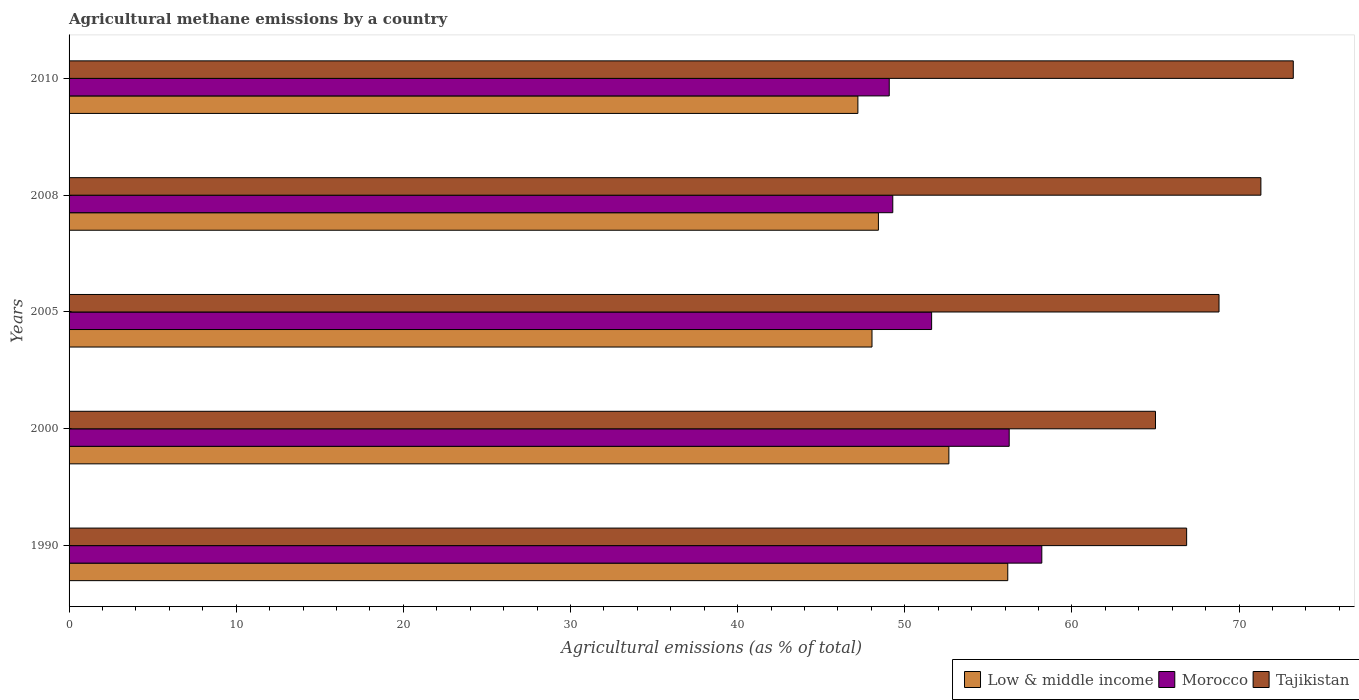Are the number of bars on each tick of the Y-axis equal?
Your answer should be compact. Yes. How many bars are there on the 3rd tick from the bottom?
Ensure brevity in your answer.  3. What is the label of the 3rd group of bars from the top?
Give a very brief answer. 2005. In how many cases, is the number of bars for a given year not equal to the number of legend labels?
Give a very brief answer. 0. What is the amount of agricultural methane emitted in Morocco in 2010?
Provide a succinct answer. 49.07. Across all years, what is the maximum amount of agricultural methane emitted in Morocco?
Give a very brief answer. 58.2. Across all years, what is the minimum amount of agricultural methane emitted in Low & middle income?
Give a very brief answer. 47.19. In which year was the amount of agricultural methane emitted in Low & middle income minimum?
Keep it short and to the point. 2010. What is the total amount of agricultural methane emitted in Low & middle income in the graph?
Provide a succinct answer. 252.44. What is the difference between the amount of agricultural methane emitted in Tajikistan in 2005 and that in 2010?
Keep it short and to the point. -4.44. What is the difference between the amount of agricultural methane emitted in Low & middle income in 1990 and the amount of agricultural methane emitted in Tajikistan in 2010?
Keep it short and to the point. -17.08. What is the average amount of agricultural methane emitted in Low & middle income per year?
Offer a terse response. 50.49. In the year 2008, what is the difference between the amount of agricultural methane emitted in Tajikistan and amount of agricultural methane emitted in Low & middle income?
Offer a very short reply. 22.88. What is the ratio of the amount of agricultural methane emitted in Low & middle income in 2000 to that in 2008?
Keep it short and to the point. 1.09. Is the difference between the amount of agricultural methane emitted in Tajikistan in 1990 and 2000 greater than the difference between the amount of agricultural methane emitted in Low & middle income in 1990 and 2000?
Your answer should be compact. No. What is the difference between the highest and the second highest amount of agricultural methane emitted in Morocco?
Provide a short and direct response. 1.95. What is the difference between the highest and the lowest amount of agricultural methane emitted in Morocco?
Make the answer very short. 9.13. What does the 1st bar from the top in 2008 represents?
Make the answer very short. Tajikistan. What does the 1st bar from the bottom in 2000 represents?
Keep it short and to the point. Low & middle income. Is it the case that in every year, the sum of the amount of agricultural methane emitted in Tajikistan and amount of agricultural methane emitted in Morocco is greater than the amount of agricultural methane emitted in Low & middle income?
Your response must be concise. Yes. Are all the bars in the graph horizontal?
Ensure brevity in your answer.  Yes. What is the difference between two consecutive major ticks on the X-axis?
Your answer should be very brief. 10. Are the values on the major ticks of X-axis written in scientific E-notation?
Give a very brief answer. No. Does the graph contain any zero values?
Provide a succinct answer. No. Where does the legend appear in the graph?
Your answer should be compact. Bottom right. How are the legend labels stacked?
Keep it short and to the point. Horizontal. What is the title of the graph?
Keep it short and to the point. Agricultural methane emissions by a country. Does "Micronesia" appear as one of the legend labels in the graph?
Provide a short and direct response. No. What is the label or title of the X-axis?
Your answer should be very brief. Agricultural emissions (as % of total). What is the Agricultural emissions (as % of total) in Low & middle income in 1990?
Ensure brevity in your answer.  56.16. What is the Agricultural emissions (as % of total) of Morocco in 1990?
Your answer should be very brief. 58.2. What is the Agricultural emissions (as % of total) of Tajikistan in 1990?
Your response must be concise. 66.86. What is the Agricultural emissions (as % of total) in Low & middle income in 2000?
Give a very brief answer. 52.63. What is the Agricultural emissions (as % of total) of Morocco in 2000?
Your answer should be very brief. 56.24. What is the Agricultural emissions (as % of total) of Tajikistan in 2000?
Ensure brevity in your answer.  65. What is the Agricultural emissions (as % of total) of Low & middle income in 2005?
Your answer should be very brief. 48.04. What is the Agricultural emissions (as % of total) of Morocco in 2005?
Your answer should be very brief. 51.6. What is the Agricultural emissions (as % of total) of Tajikistan in 2005?
Offer a terse response. 68.8. What is the Agricultural emissions (as % of total) in Low & middle income in 2008?
Offer a terse response. 48.42. What is the Agricultural emissions (as % of total) of Morocco in 2008?
Offer a very short reply. 49.28. What is the Agricultural emissions (as % of total) of Tajikistan in 2008?
Make the answer very short. 71.3. What is the Agricultural emissions (as % of total) of Low & middle income in 2010?
Provide a short and direct response. 47.19. What is the Agricultural emissions (as % of total) in Morocco in 2010?
Your answer should be compact. 49.07. What is the Agricultural emissions (as % of total) in Tajikistan in 2010?
Your response must be concise. 73.24. Across all years, what is the maximum Agricultural emissions (as % of total) in Low & middle income?
Keep it short and to the point. 56.16. Across all years, what is the maximum Agricultural emissions (as % of total) in Morocco?
Your response must be concise. 58.2. Across all years, what is the maximum Agricultural emissions (as % of total) of Tajikistan?
Your answer should be very brief. 73.24. Across all years, what is the minimum Agricultural emissions (as % of total) in Low & middle income?
Ensure brevity in your answer.  47.19. Across all years, what is the minimum Agricultural emissions (as % of total) of Morocco?
Make the answer very short. 49.07. Across all years, what is the minimum Agricultural emissions (as % of total) of Tajikistan?
Provide a short and direct response. 65. What is the total Agricultural emissions (as % of total) in Low & middle income in the graph?
Offer a very short reply. 252.44. What is the total Agricultural emissions (as % of total) in Morocco in the graph?
Offer a very short reply. 264.39. What is the total Agricultural emissions (as % of total) in Tajikistan in the graph?
Offer a terse response. 345.19. What is the difference between the Agricultural emissions (as % of total) in Low & middle income in 1990 and that in 2000?
Keep it short and to the point. 3.52. What is the difference between the Agricultural emissions (as % of total) of Morocco in 1990 and that in 2000?
Your answer should be compact. 1.95. What is the difference between the Agricultural emissions (as % of total) of Tajikistan in 1990 and that in 2000?
Provide a short and direct response. 1.86. What is the difference between the Agricultural emissions (as % of total) of Low & middle income in 1990 and that in 2005?
Make the answer very short. 8.12. What is the difference between the Agricultural emissions (as % of total) of Morocco in 1990 and that in 2005?
Offer a terse response. 6.59. What is the difference between the Agricultural emissions (as % of total) of Tajikistan in 1990 and that in 2005?
Your answer should be compact. -1.94. What is the difference between the Agricultural emissions (as % of total) of Low & middle income in 1990 and that in 2008?
Your response must be concise. 7.74. What is the difference between the Agricultural emissions (as % of total) in Morocco in 1990 and that in 2008?
Offer a very short reply. 8.92. What is the difference between the Agricultural emissions (as % of total) in Tajikistan in 1990 and that in 2008?
Your answer should be very brief. -4.44. What is the difference between the Agricultural emissions (as % of total) in Low & middle income in 1990 and that in 2010?
Your answer should be very brief. 8.97. What is the difference between the Agricultural emissions (as % of total) of Morocco in 1990 and that in 2010?
Your answer should be very brief. 9.13. What is the difference between the Agricultural emissions (as % of total) of Tajikistan in 1990 and that in 2010?
Offer a very short reply. -6.38. What is the difference between the Agricultural emissions (as % of total) of Low & middle income in 2000 and that in 2005?
Your answer should be very brief. 4.6. What is the difference between the Agricultural emissions (as % of total) in Morocco in 2000 and that in 2005?
Provide a short and direct response. 4.64. What is the difference between the Agricultural emissions (as % of total) in Tajikistan in 2000 and that in 2005?
Keep it short and to the point. -3.8. What is the difference between the Agricultural emissions (as % of total) in Low & middle income in 2000 and that in 2008?
Keep it short and to the point. 4.22. What is the difference between the Agricultural emissions (as % of total) of Morocco in 2000 and that in 2008?
Provide a short and direct response. 6.97. What is the difference between the Agricultural emissions (as % of total) in Tajikistan in 2000 and that in 2008?
Offer a terse response. -6.31. What is the difference between the Agricultural emissions (as % of total) in Low & middle income in 2000 and that in 2010?
Offer a very short reply. 5.44. What is the difference between the Agricultural emissions (as % of total) of Morocco in 2000 and that in 2010?
Offer a very short reply. 7.18. What is the difference between the Agricultural emissions (as % of total) of Tajikistan in 2000 and that in 2010?
Keep it short and to the point. -8.24. What is the difference between the Agricultural emissions (as % of total) of Low & middle income in 2005 and that in 2008?
Your response must be concise. -0.38. What is the difference between the Agricultural emissions (as % of total) in Morocco in 2005 and that in 2008?
Offer a terse response. 2.32. What is the difference between the Agricultural emissions (as % of total) of Tajikistan in 2005 and that in 2008?
Your response must be concise. -2.51. What is the difference between the Agricultural emissions (as % of total) of Low & middle income in 2005 and that in 2010?
Offer a terse response. 0.84. What is the difference between the Agricultural emissions (as % of total) of Morocco in 2005 and that in 2010?
Give a very brief answer. 2.53. What is the difference between the Agricultural emissions (as % of total) of Tajikistan in 2005 and that in 2010?
Your answer should be compact. -4.44. What is the difference between the Agricultural emissions (as % of total) of Low & middle income in 2008 and that in 2010?
Your answer should be very brief. 1.23. What is the difference between the Agricultural emissions (as % of total) in Morocco in 2008 and that in 2010?
Make the answer very short. 0.21. What is the difference between the Agricultural emissions (as % of total) of Tajikistan in 2008 and that in 2010?
Provide a short and direct response. -1.94. What is the difference between the Agricultural emissions (as % of total) in Low & middle income in 1990 and the Agricultural emissions (as % of total) in Morocco in 2000?
Offer a very short reply. -0.09. What is the difference between the Agricultural emissions (as % of total) of Low & middle income in 1990 and the Agricultural emissions (as % of total) of Tajikistan in 2000?
Ensure brevity in your answer.  -8.84. What is the difference between the Agricultural emissions (as % of total) of Morocco in 1990 and the Agricultural emissions (as % of total) of Tajikistan in 2000?
Make the answer very short. -6.8. What is the difference between the Agricultural emissions (as % of total) in Low & middle income in 1990 and the Agricultural emissions (as % of total) in Morocco in 2005?
Provide a short and direct response. 4.56. What is the difference between the Agricultural emissions (as % of total) of Low & middle income in 1990 and the Agricultural emissions (as % of total) of Tajikistan in 2005?
Your answer should be very brief. -12.64. What is the difference between the Agricultural emissions (as % of total) of Morocco in 1990 and the Agricultural emissions (as % of total) of Tajikistan in 2005?
Offer a terse response. -10.6. What is the difference between the Agricultural emissions (as % of total) in Low & middle income in 1990 and the Agricultural emissions (as % of total) in Morocco in 2008?
Offer a very short reply. 6.88. What is the difference between the Agricultural emissions (as % of total) in Low & middle income in 1990 and the Agricultural emissions (as % of total) in Tajikistan in 2008?
Keep it short and to the point. -15.14. What is the difference between the Agricultural emissions (as % of total) in Morocco in 1990 and the Agricultural emissions (as % of total) in Tajikistan in 2008?
Keep it short and to the point. -13.11. What is the difference between the Agricultural emissions (as % of total) in Low & middle income in 1990 and the Agricultural emissions (as % of total) in Morocco in 2010?
Provide a short and direct response. 7.09. What is the difference between the Agricultural emissions (as % of total) in Low & middle income in 1990 and the Agricultural emissions (as % of total) in Tajikistan in 2010?
Provide a succinct answer. -17.08. What is the difference between the Agricultural emissions (as % of total) in Morocco in 1990 and the Agricultural emissions (as % of total) in Tajikistan in 2010?
Make the answer very short. -15.04. What is the difference between the Agricultural emissions (as % of total) of Low & middle income in 2000 and the Agricultural emissions (as % of total) of Morocco in 2005?
Your answer should be compact. 1.03. What is the difference between the Agricultural emissions (as % of total) of Low & middle income in 2000 and the Agricultural emissions (as % of total) of Tajikistan in 2005?
Your answer should be very brief. -16.16. What is the difference between the Agricultural emissions (as % of total) in Morocco in 2000 and the Agricultural emissions (as % of total) in Tajikistan in 2005?
Your response must be concise. -12.55. What is the difference between the Agricultural emissions (as % of total) in Low & middle income in 2000 and the Agricultural emissions (as % of total) in Morocco in 2008?
Make the answer very short. 3.36. What is the difference between the Agricultural emissions (as % of total) in Low & middle income in 2000 and the Agricultural emissions (as % of total) in Tajikistan in 2008?
Ensure brevity in your answer.  -18.67. What is the difference between the Agricultural emissions (as % of total) in Morocco in 2000 and the Agricultural emissions (as % of total) in Tajikistan in 2008?
Ensure brevity in your answer.  -15.06. What is the difference between the Agricultural emissions (as % of total) in Low & middle income in 2000 and the Agricultural emissions (as % of total) in Morocco in 2010?
Your answer should be compact. 3.57. What is the difference between the Agricultural emissions (as % of total) in Low & middle income in 2000 and the Agricultural emissions (as % of total) in Tajikistan in 2010?
Keep it short and to the point. -20.6. What is the difference between the Agricultural emissions (as % of total) in Morocco in 2000 and the Agricultural emissions (as % of total) in Tajikistan in 2010?
Your answer should be compact. -17. What is the difference between the Agricultural emissions (as % of total) of Low & middle income in 2005 and the Agricultural emissions (as % of total) of Morocco in 2008?
Your answer should be compact. -1.24. What is the difference between the Agricultural emissions (as % of total) of Low & middle income in 2005 and the Agricultural emissions (as % of total) of Tajikistan in 2008?
Your response must be concise. -23.27. What is the difference between the Agricultural emissions (as % of total) in Morocco in 2005 and the Agricultural emissions (as % of total) in Tajikistan in 2008?
Keep it short and to the point. -19.7. What is the difference between the Agricultural emissions (as % of total) in Low & middle income in 2005 and the Agricultural emissions (as % of total) in Morocco in 2010?
Give a very brief answer. -1.03. What is the difference between the Agricultural emissions (as % of total) of Low & middle income in 2005 and the Agricultural emissions (as % of total) of Tajikistan in 2010?
Your response must be concise. -25.2. What is the difference between the Agricultural emissions (as % of total) of Morocco in 2005 and the Agricultural emissions (as % of total) of Tajikistan in 2010?
Keep it short and to the point. -21.64. What is the difference between the Agricultural emissions (as % of total) in Low & middle income in 2008 and the Agricultural emissions (as % of total) in Morocco in 2010?
Ensure brevity in your answer.  -0.65. What is the difference between the Agricultural emissions (as % of total) of Low & middle income in 2008 and the Agricultural emissions (as % of total) of Tajikistan in 2010?
Ensure brevity in your answer.  -24.82. What is the difference between the Agricultural emissions (as % of total) of Morocco in 2008 and the Agricultural emissions (as % of total) of Tajikistan in 2010?
Keep it short and to the point. -23.96. What is the average Agricultural emissions (as % of total) in Low & middle income per year?
Ensure brevity in your answer.  50.49. What is the average Agricultural emissions (as % of total) in Morocco per year?
Ensure brevity in your answer.  52.88. What is the average Agricultural emissions (as % of total) of Tajikistan per year?
Your answer should be compact. 69.04. In the year 1990, what is the difference between the Agricultural emissions (as % of total) in Low & middle income and Agricultural emissions (as % of total) in Morocco?
Your answer should be very brief. -2.04. In the year 1990, what is the difference between the Agricultural emissions (as % of total) of Low & middle income and Agricultural emissions (as % of total) of Tajikistan?
Give a very brief answer. -10.7. In the year 1990, what is the difference between the Agricultural emissions (as % of total) in Morocco and Agricultural emissions (as % of total) in Tajikistan?
Ensure brevity in your answer.  -8.66. In the year 2000, what is the difference between the Agricultural emissions (as % of total) in Low & middle income and Agricultural emissions (as % of total) in Morocco?
Your answer should be very brief. -3.61. In the year 2000, what is the difference between the Agricultural emissions (as % of total) in Low & middle income and Agricultural emissions (as % of total) in Tajikistan?
Give a very brief answer. -12.36. In the year 2000, what is the difference between the Agricultural emissions (as % of total) in Morocco and Agricultural emissions (as % of total) in Tajikistan?
Ensure brevity in your answer.  -8.75. In the year 2005, what is the difference between the Agricultural emissions (as % of total) in Low & middle income and Agricultural emissions (as % of total) in Morocco?
Offer a very short reply. -3.57. In the year 2005, what is the difference between the Agricultural emissions (as % of total) in Low & middle income and Agricultural emissions (as % of total) in Tajikistan?
Keep it short and to the point. -20.76. In the year 2005, what is the difference between the Agricultural emissions (as % of total) in Morocco and Agricultural emissions (as % of total) in Tajikistan?
Provide a short and direct response. -17.19. In the year 2008, what is the difference between the Agricultural emissions (as % of total) in Low & middle income and Agricultural emissions (as % of total) in Morocco?
Make the answer very short. -0.86. In the year 2008, what is the difference between the Agricultural emissions (as % of total) in Low & middle income and Agricultural emissions (as % of total) in Tajikistan?
Ensure brevity in your answer.  -22.88. In the year 2008, what is the difference between the Agricultural emissions (as % of total) of Morocco and Agricultural emissions (as % of total) of Tajikistan?
Provide a succinct answer. -22.02. In the year 2010, what is the difference between the Agricultural emissions (as % of total) in Low & middle income and Agricultural emissions (as % of total) in Morocco?
Give a very brief answer. -1.88. In the year 2010, what is the difference between the Agricultural emissions (as % of total) of Low & middle income and Agricultural emissions (as % of total) of Tajikistan?
Offer a terse response. -26.05. In the year 2010, what is the difference between the Agricultural emissions (as % of total) of Morocco and Agricultural emissions (as % of total) of Tajikistan?
Provide a succinct answer. -24.17. What is the ratio of the Agricultural emissions (as % of total) in Low & middle income in 1990 to that in 2000?
Provide a succinct answer. 1.07. What is the ratio of the Agricultural emissions (as % of total) in Morocco in 1990 to that in 2000?
Provide a succinct answer. 1.03. What is the ratio of the Agricultural emissions (as % of total) of Tajikistan in 1990 to that in 2000?
Keep it short and to the point. 1.03. What is the ratio of the Agricultural emissions (as % of total) of Low & middle income in 1990 to that in 2005?
Provide a short and direct response. 1.17. What is the ratio of the Agricultural emissions (as % of total) in Morocco in 1990 to that in 2005?
Offer a terse response. 1.13. What is the ratio of the Agricultural emissions (as % of total) in Tajikistan in 1990 to that in 2005?
Keep it short and to the point. 0.97. What is the ratio of the Agricultural emissions (as % of total) of Low & middle income in 1990 to that in 2008?
Your answer should be very brief. 1.16. What is the ratio of the Agricultural emissions (as % of total) of Morocco in 1990 to that in 2008?
Provide a short and direct response. 1.18. What is the ratio of the Agricultural emissions (as % of total) of Tajikistan in 1990 to that in 2008?
Offer a terse response. 0.94. What is the ratio of the Agricultural emissions (as % of total) of Low & middle income in 1990 to that in 2010?
Ensure brevity in your answer.  1.19. What is the ratio of the Agricultural emissions (as % of total) of Morocco in 1990 to that in 2010?
Make the answer very short. 1.19. What is the ratio of the Agricultural emissions (as % of total) in Tajikistan in 1990 to that in 2010?
Your answer should be compact. 0.91. What is the ratio of the Agricultural emissions (as % of total) in Low & middle income in 2000 to that in 2005?
Offer a terse response. 1.1. What is the ratio of the Agricultural emissions (as % of total) in Morocco in 2000 to that in 2005?
Give a very brief answer. 1.09. What is the ratio of the Agricultural emissions (as % of total) of Tajikistan in 2000 to that in 2005?
Offer a very short reply. 0.94. What is the ratio of the Agricultural emissions (as % of total) in Low & middle income in 2000 to that in 2008?
Your answer should be compact. 1.09. What is the ratio of the Agricultural emissions (as % of total) of Morocco in 2000 to that in 2008?
Make the answer very short. 1.14. What is the ratio of the Agricultural emissions (as % of total) of Tajikistan in 2000 to that in 2008?
Offer a very short reply. 0.91. What is the ratio of the Agricultural emissions (as % of total) in Low & middle income in 2000 to that in 2010?
Make the answer very short. 1.12. What is the ratio of the Agricultural emissions (as % of total) of Morocco in 2000 to that in 2010?
Offer a terse response. 1.15. What is the ratio of the Agricultural emissions (as % of total) in Tajikistan in 2000 to that in 2010?
Your response must be concise. 0.89. What is the ratio of the Agricultural emissions (as % of total) of Morocco in 2005 to that in 2008?
Make the answer very short. 1.05. What is the ratio of the Agricultural emissions (as % of total) in Tajikistan in 2005 to that in 2008?
Your answer should be compact. 0.96. What is the ratio of the Agricultural emissions (as % of total) in Low & middle income in 2005 to that in 2010?
Your answer should be very brief. 1.02. What is the ratio of the Agricultural emissions (as % of total) of Morocco in 2005 to that in 2010?
Give a very brief answer. 1.05. What is the ratio of the Agricultural emissions (as % of total) in Tajikistan in 2005 to that in 2010?
Provide a short and direct response. 0.94. What is the ratio of the Agricultural emissions (as % of total) in Morocco in 2008 to that in 2010?
Provide a succinct answer. 1. What is the ratio of the Agricultural emissions (as % of total) of Tajikistan in 2008 to that in 2010?
Provide a succinct answer. 0.97. What is the difference between the highest and the second highest Agricultural emissions (as % of total) of Low & middle income?
Your response must be concise. 3.52. What is the difference between the highest and the second highest Agricultural emissions (as % of total) of Morocco?
Provide a short and direct response. 1.95. What is the difference between the highest and the second highest Agricultural emissions (as % of total) of Tajikistan?
Ensure brevity in your answer.  1.94. What is the difference between the highest and the lowest Agricultural emissions (as % of total) of Low & middle income?
Offer a very short reply. 8.97. What is the difference between the highest and the lowest Agricultural emissions (as % of total) in Morocco?
Keep it short and to the point. 9.13. What is the difference between the highest and the lowest Agricultural emissions (as % of total) in Tajikistan?
Make the answer very short. 8.24. 